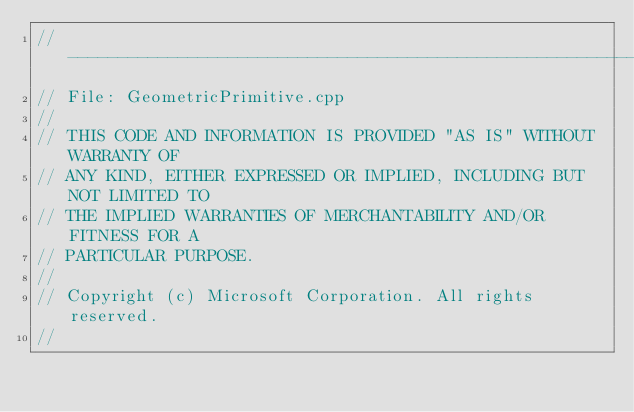Convert code to text. <code><loc_0><loc_0><loc_500><loc_500><_C++_>//--------------------------------------------------------------------------------------
// File: GeometricPrimitive.cpp
//
// THIS CODE AND INFORMATION IS PROVIDED "AS IS" WITHOUT WARRANTY OF
// ANY KIND, EITHER EXPRESSED OR IMPLIED, INCLUDING BUT NOT LIMITED TO
// THE IMPLIED WARRANTIES OF MERCHANTABILITY AND/OR FITNESS FOR A
// PARTICULAR PURPOSE.
//
// Copyright (c) Microsoft Corporation. All rights reserved.
//</code> 